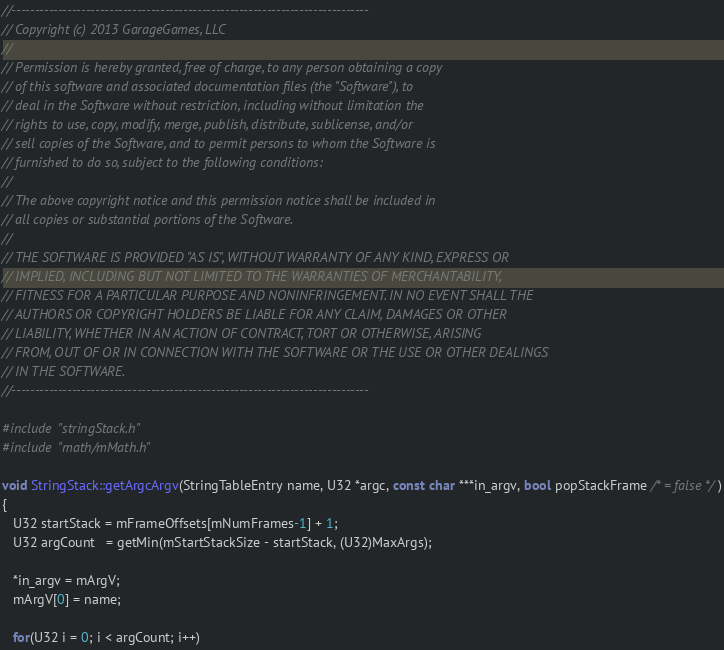<code> <loc_0><loc_0><loc_500><loc_500><_C++_>//-----------------------------------------------------------------------------
// Copyright (c) 2013 GarageGames, LLC
//
// Permission is hereby granted, free of charge, to any person obtaining a copy
// of this software and associated documentation files (the "Software"), to
// deal in the Software without restriction, including without limitation the
// rights to use, copy, modify, merge, publish, distribute, sublicense, and/or
// sell copies of the Software, and to permit persons to whom the Software is
// furnished to do so, subject to the following conditions:
//
// The above copyright notice and this permission notice shall be included in
// all copies or substantial portions of the Software.
//
// THE SOFTWARE IS PROVIDED "AS IS", WITHOUT WARRANTY OF ANY KIND, EXPRESS OR
// IMPLIED, INCLUDING BUT NOT LIMITED TO THE WARRANTIES OF MERCHANTABILITY,
// FITNESS FOR A PARTICULAR PURPOSE AND NONINFRINGEMENT. IN NO EVENT SHALL THE
// AUTHORS OR COPYRIGHT HOLDERS BE LIABLE FOR ANY CLAIM, DAMAGES OR OTHER
// LIABILITY, WHETHER IN AN ACTION OF CONTRACT, TORT OR OTHERWISE, ARISING
// FROM, OUT OF OR IN CONNECTION WITH THE SOFTWARE OR THE USE OR OTHER DEALINGS
// IN THE SOFTWARE.
//-----------------------------------------------------------------------------

#include "stringStack.h"
#include "math/mMath.h"

void StringStack::getArgcArgv(StringTableEntry name, U32 *argc, const char ***in_argv, bool popStackFrame /* = false */)
{
   U32 startStack = mFrameOffsets[mNumFrames-1] + 1;
   U32 argCount   = getMin(mStartStackSize - startStack, (U32)MaxArgs);

   *in_argv = mArgV;
   mArgV[0] = name;
   
   for(U32 i = 0; i < argCount; i++)</code> 